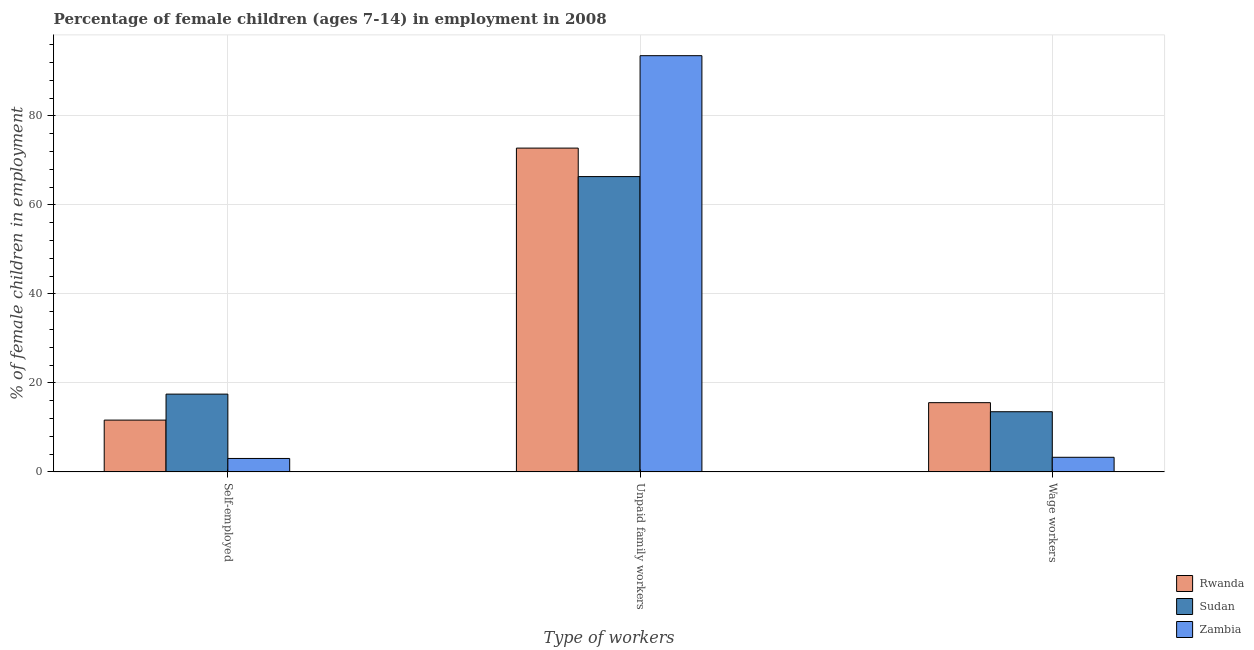Are the number of bars on each tick of the X-axis equal?
Provide a succinct answer. Yes. How many bars are there on the 3rd tick from the left?
Offer a terse response. 3. What is the label of the 2nd group of bars from the left?
Keep it short and to the point. Unpaid family workers. What is the percentage of children employed as wage workers in Sudan?
Offer a terse response. 13.53. Across all countries, what is the maximum percentage of children employed as unpaid family workers?
Provide a short and direct response. 93.55. Across all countries, what is the minimum percentage of self employed children?
Your answer should be compact. 3.03. In which country was the percentage of children employed as wage workers maximum?
Keep it short and to the point. Rwanda. In which country was the percentage of children employed as unpaid family workers minimum?
Offer a terse response. Sudan. What is the total percentage of children employed as unpaid family workers in the graph?
Your response must be concise. 232.71. What is the difference between the percentage of self employed children in Sudan and that in Rwanda?
Give a very brief answer. 5.84. What is the difference between the percentage of self employed children in Zambia and the percentage of children employed as unpaid family workers in Sudan?
Your answer should be very brief. -63.35. What is the average percentage of children employed as wage workers per country?
Offer a terse response. 10.8. What is the difference between the percentage of children employed as wage workers and percentage of children employed as unpaid family workers in Zambia?
Keep it short and to the point. -90.26. What is the ratio of the percentage of children employed as unpaid family workers in Sudan to that in Rwanda?
Give a very brief answer. 0.91. Is the percentage of children employed as wage workers in Sudan less than that in Rwanda?
Your response must be concise. Yes. What is the difference between the highest and the second highest percentage of self employed children?
Your answer should be very brief. 5.84. What is the difference between the highest and the lowest percentage of children employed as wage workers?
Make the answer very short. 12.28. What does the 1st bar from the left in Unpaid family workers represents?
Keep it short and to the point. Rwanda. What does the 3rd bar from the right in Self-employed represents?
Ensure brevity in your answer.  Rwanda. How many bars are there?
Offer a terse response. 9. Are all the bars in the graph horizontal?
Your answer should be very brief. No. How many countries are there in the graph?
Provide a short and direct response. 3. Does the graph contain grids?
Provide a short and direct response. Yes. Where does the legend appear in the graph?
Ensure brevity in your answer.  Bottom right. How many legend labels are there?
Provide a succinct answer. 3. What is the title of the graph?
Your answer should be compact. Percentage of female children (ages 7-14) in employment in 2008. Does "Europe(all income levels)" appear as one of the legend labels in the graph?
Your answer should be compact. No. What is the label or title of the X-axis?
Make the answer very short. Type of workers. What is the label or title of the Y-axis?
Offer a very short reply. % of female children in employment. What is the % of female children in employment in Rwanda in Self-employed?
Your response must be concise. 11.65. What is the % of female children in employment of Sudan in Self-employed?
Keep it short and to the point. 17.49. What is the % of female children in employment of Zambia in Self-employed?
Provide a short and direct response. 3.03. What is the % of female children in employment of Rwanda in Unpaid family workers?
Keep it short and to the point. 72.78. What is the % of female children in employment of Sudan in Unpaid family workers?
Your response must be concise. 66.38. What is the % of female children in employment of Zambia in Unpaid family workers?
Offer a terse response. 93.55. What is the % of female children in employment in Rwanda in Wage workers?
Offer a terse response. 15.57. What is the % of female children in employment in Sudan in Wage workers?
Offer a very short reply. 13.53. What is the % of female children in employment of Zambia in Wage workers?
Provide a short and direct response. 3.29. Across all Type of workers, what is the maximum % of female children in employment of Rwanda?
Your answer should be very brief. 72.78. Across all Type of workers, what is the maximum % of female children in employment of Sudan?
Your answer should be very brief. 66.38. Across all Type of workers, what is the maximum % of female children in employment of Zambia?
Offer a terse response. 93.55. Across all Type of workers, what is the minimum % of female children in employment in Rwanda?
Your answer should be very brief. 11.65. Across all Type of workers, what is the minimum % of female children in employment in Sudan?
Keep it short and to the point. 13.53. Across all Type of workers, what is the minimum % of female children in employment in Zambia?
Give a very brief answer. 3.03. What is the total % of female children in employment in Rwanda in the graph?
Offer a terse response. 100. What is the total % of female children in employment in Sudan in the graph?
Offer a terse response. 97.4. What is the total % of female children in employment of Zambia in the graph?
Offer a terse response. 99.87. What is the difference between the % of female children in employment of Rwanda in Self-employed and that in Unpaid family workers?
Your answer should be compact. -61.13. What is the difference between the % of female children in employment of Sudan in Self-employed and that in Unpaid family workers?
Provide a short and direct response. -48.89. What is the difference between the % of female children in employment in Zambia in Self-employed and that in Unpaid family workers?
Your response must be concise. -90.52. What is the difference between the % of female children in employment in Rwanda in Self-employed and that in Wage workers?
Provide a succinct answer. -3.92. What is the difference between the % of female children in employment in Sudan in Self-employed and that in Wage workers?
Your answer should be compact. 3.96. What is the difference between the % of female children in employment of Zambia in Self-employed and that in Wage workers?
Provide a short and direct response. -0.26. What is the difference between the % of female children in employment in Rwanda in Unpaid family workers and that in Wage workers?
Your response must be concise. 57.21. What is the difference between the % of female children in employment of Sudan in Unpaid family workers and that in Wage workers?
Ensure brevity in your answer.  52.85. What is the difference between the % of female children in employment in Zambia in Unpaid family workers and that in Wage workers?
Give a very brief answer. 90.26. What is the difference between the % of female children in employment of Rwanda in Self-employed and the % of female children in employment of Sudan in Unpaid family workers?
Offer a terse response. -54.73. What is the difference between the % of female children in employment in Rwanda in Self-employed and the % of female children in employment in Zambia in Unpaid family workers?
Provide a short and direct response. -81.9. What is the difference between the % of female children in employment of Sudan in Self-employed and the % of female children in employment of Zambia in Unpaid family workers?
Offer a terse response. -76.06. What is the difference between the % of female children in employment in Rwanda in Self-employed and the % of female children in employment in Sudan in Wage workers?
Offer a terse response. -1.88. What is the difference between the % of female children in employment in Rwanda in Self-employed and the % of female children in employment in Zambia in Wage workers?
Offer a very short reply. 8.36. What is the difference between the % of female children in employment of Sudan in Self-employed and the % of female children in employment of Zambia in Wage workers?
Offer a very short reply. 14.2. What is the difference between the % of female children in employment of Rwanda in Unpaid family workers and the % of female children in employment of Sudan in Wage workers?
Give a very brief answer. 59.25. What is the difference between the % of female children in employment in Rwanda in Unpaid family workers and the % of female children in employment in Zambia in Wage workers?
Provide a short and direct response. 69.49. What is the difference between the % of female children in employment in Sudan in Unpaid family workers and the % of female children in employment in Zambia in Wage workers?
Give a very brief answer. 63.09. What is the average % of female children in employment in Rwanda per Type of workers?
Provide a short and direct response. 33.33. What is the average % of female children in employment in Sudan per Type of workers?
Offer a terse response. 32.47. What is the average % of female children in employment of Zambia per Type of workers?
Your answer should be very brief. 33.29. What is the difference between the % of female children in employment of Rwanda and % of female children in employment of Sudan in Self-employed?
Your answer should be compact. -5.84. What is the difference between the % of female children in employment in Rwanda and % of female children in employment in Zambia in Self-employed?
Your answer should be very brief. 8.62. What is the difference between the % of female children in employment in Sudan and % of female children in employment in Zambia in Self-employed?
Ensure brevity in your answer.  14.46. What is the difference between the % of female children in employment in Rwanda and % of female children in employment in Zambia in Unpaid family workers?
Provide a short and direct response. -20.77. What is the difference between the % of female children in employment of Sudan and % of female children in employment of Zambia in Unpaid family workers?
Your answer should be very brief. -27.17. What is the difference between the % of female children in employment of Rwanda and % of female children in employment of Sudan in Wage workers?
Offer a very short reply. 2.04. What is the difference between the % of female children in employment of Rwanda and % of female children in employment of Zambia in Wage workers?
Provide a succinct answer. 12.28. What is the difference between the % of female children in employment of Sudan and % of female children in employment of Zambia in Wage workers?
Your response must be concise. 10.24. What is the ratio of the % of female children in employment of Rwanda in Self-employed to that in Unpaid family workers?
Provide a short and direct response. 0.16. What is the ratio of the % of female children in employment in Sudan in Self-employed to that in Unpaid family workers?
Make the answer very short. 0.26. What is the ratio of the % of female children in employment of Zambia in Self-employed to that in Unpaid family workers?
Your answer should be compact. 0.03. What is the ratio of the % of female children in employment in Rwanda in Self-employed to that in Wage workers?
Provide a short and direct response. 0.75. What is the ratio of the % of female children in employment of Sudan in Self-employed to that in Wage workers?
Give a very brief answer. 1.29. What is the ratio of the % of female children in employment of Zambia in Self-employed to that in Wage workers?
Your response must be concise. 0.92. What is the ratio of the % of female children in employment in Rwanda in Unpaid family workers to that in Wage workers?
Give a very brief answer. 4.67. What is the ratio of the % of female children in employment in Sudan in Unpaid family workers to that in Wage workers?
Your answer should be very brief. 4.91. What is the ratio of the % of female children in employment in Zambia in Unpaid family workers to that in Wage workers?
Offer a very short reply. 28.43. What is the difference between the highest and the second highest % of female children in employment in Rwanda?
Offer a very short reply. 57.21. What is the difference between the highest and the second highest % of female children in employment of Sudan?
Offer a very short reply. 48.89. What is the difference between the highest and the second highest % of female children in employment in Zambia?
Keep it short and to the point. 90.26. What is the difference between the highest and the lowest % of female children in employment in Rwanda?
Provide a short and direct response. 61.13. What is the difference between the highest and the lowest % of female children in employment in Sudan?
Give a very brief answer. 52.85. What is the difference between the highest and the lowest % of female children in employment in Zambia?
Keep it short and to the point. 90.52. 